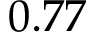Convert formula to latex. <formula><loc_0><loc_0><loc_500><loc_500>0 . 7 7</formula> 